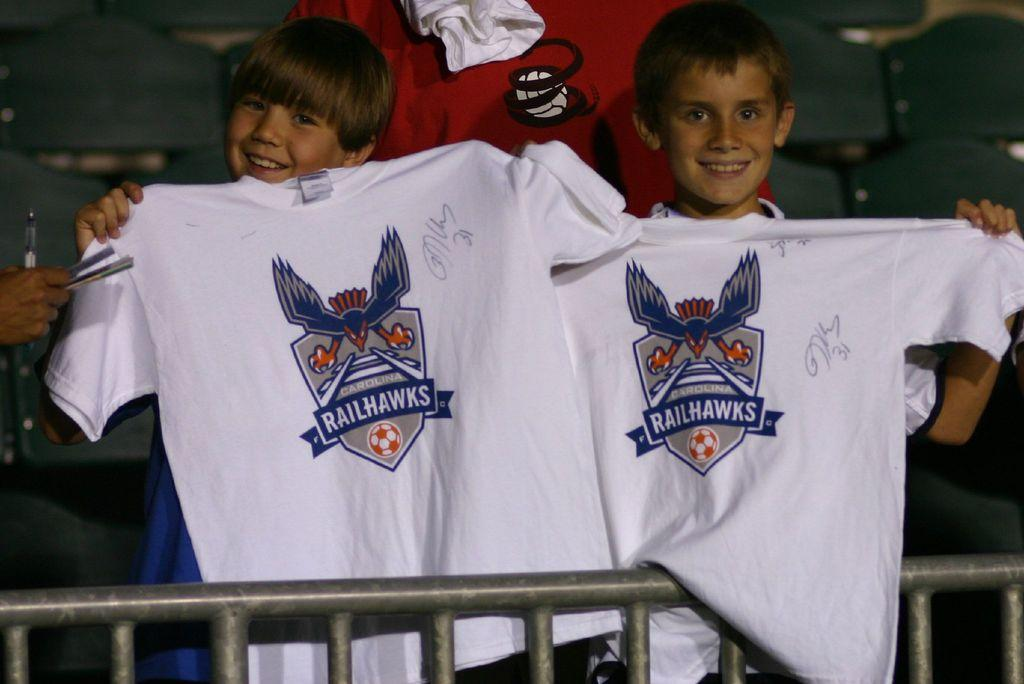How many children are in the image? There are two children in the image. What are the children holding in the image? The children are holding T-shirts in the image. Can you describe the hand of a person in the image? There is a hand of a person holding some objects in the image. What else can be seen in the image besides the children and the hand? There are clothes visible in the image. What is visible in the background of the image? There are chairs in the background of the image. What type of stitch is used to sew the cloth in the image? There is no cloth or stitching present in the image; it features two children holding T-shirts and a hand holding some objects. What is the range of the objects being held by the hand in the image? The image does not provide information about the range of the objects being held by the hand. 